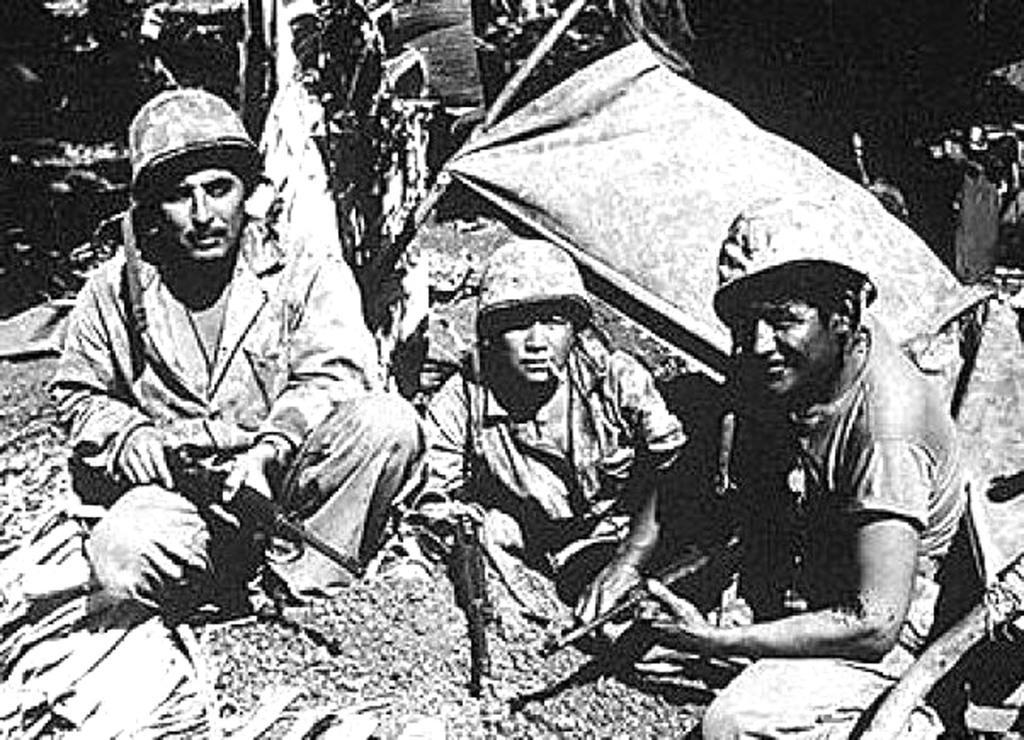Describe this image in one or two sentences. This is a black and white image. There are three persons in this image. They look like military people. They are holding guns and wearing helmets. 